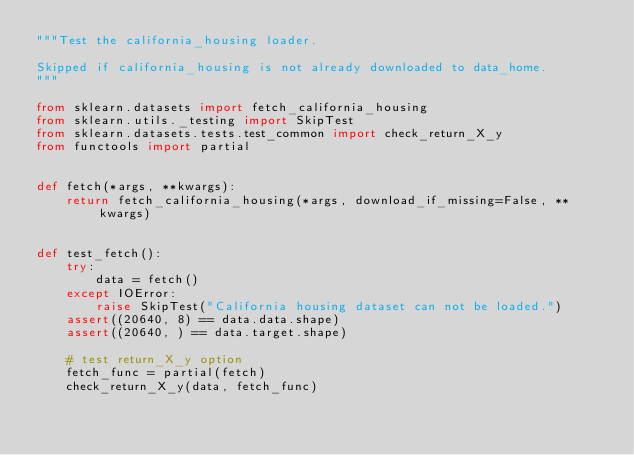<code> <loc_0><loc_0><loc_500><loc_500><_Python_>"""Test the california_housing loader.

Skipped if california_housing is not already downloaded to data_home.
"""

from sklearn.datasets import fetch_california_housing
from sklearn.utils._testing import SkipTest
from sklearn.datasets.tests.test_common import check_return_X_y
from functools import partial


def fetch(*args, **kwargs):
    return fetch_california_housing(*args, download_if_missing=False, **kwargs)


def test_fetch():
    try:
        data = fetch()
    except IOError:
        raise SkipTest("California housing dataset can not be loaded.")
    assert((20640, 8) == data.data.shape)
    assert((20640, ) == data.target.shape)

    # test return_X_y option
    fetch_func = partial(fetch)
    check_return_X_y(data, fetch_func)
</code> 